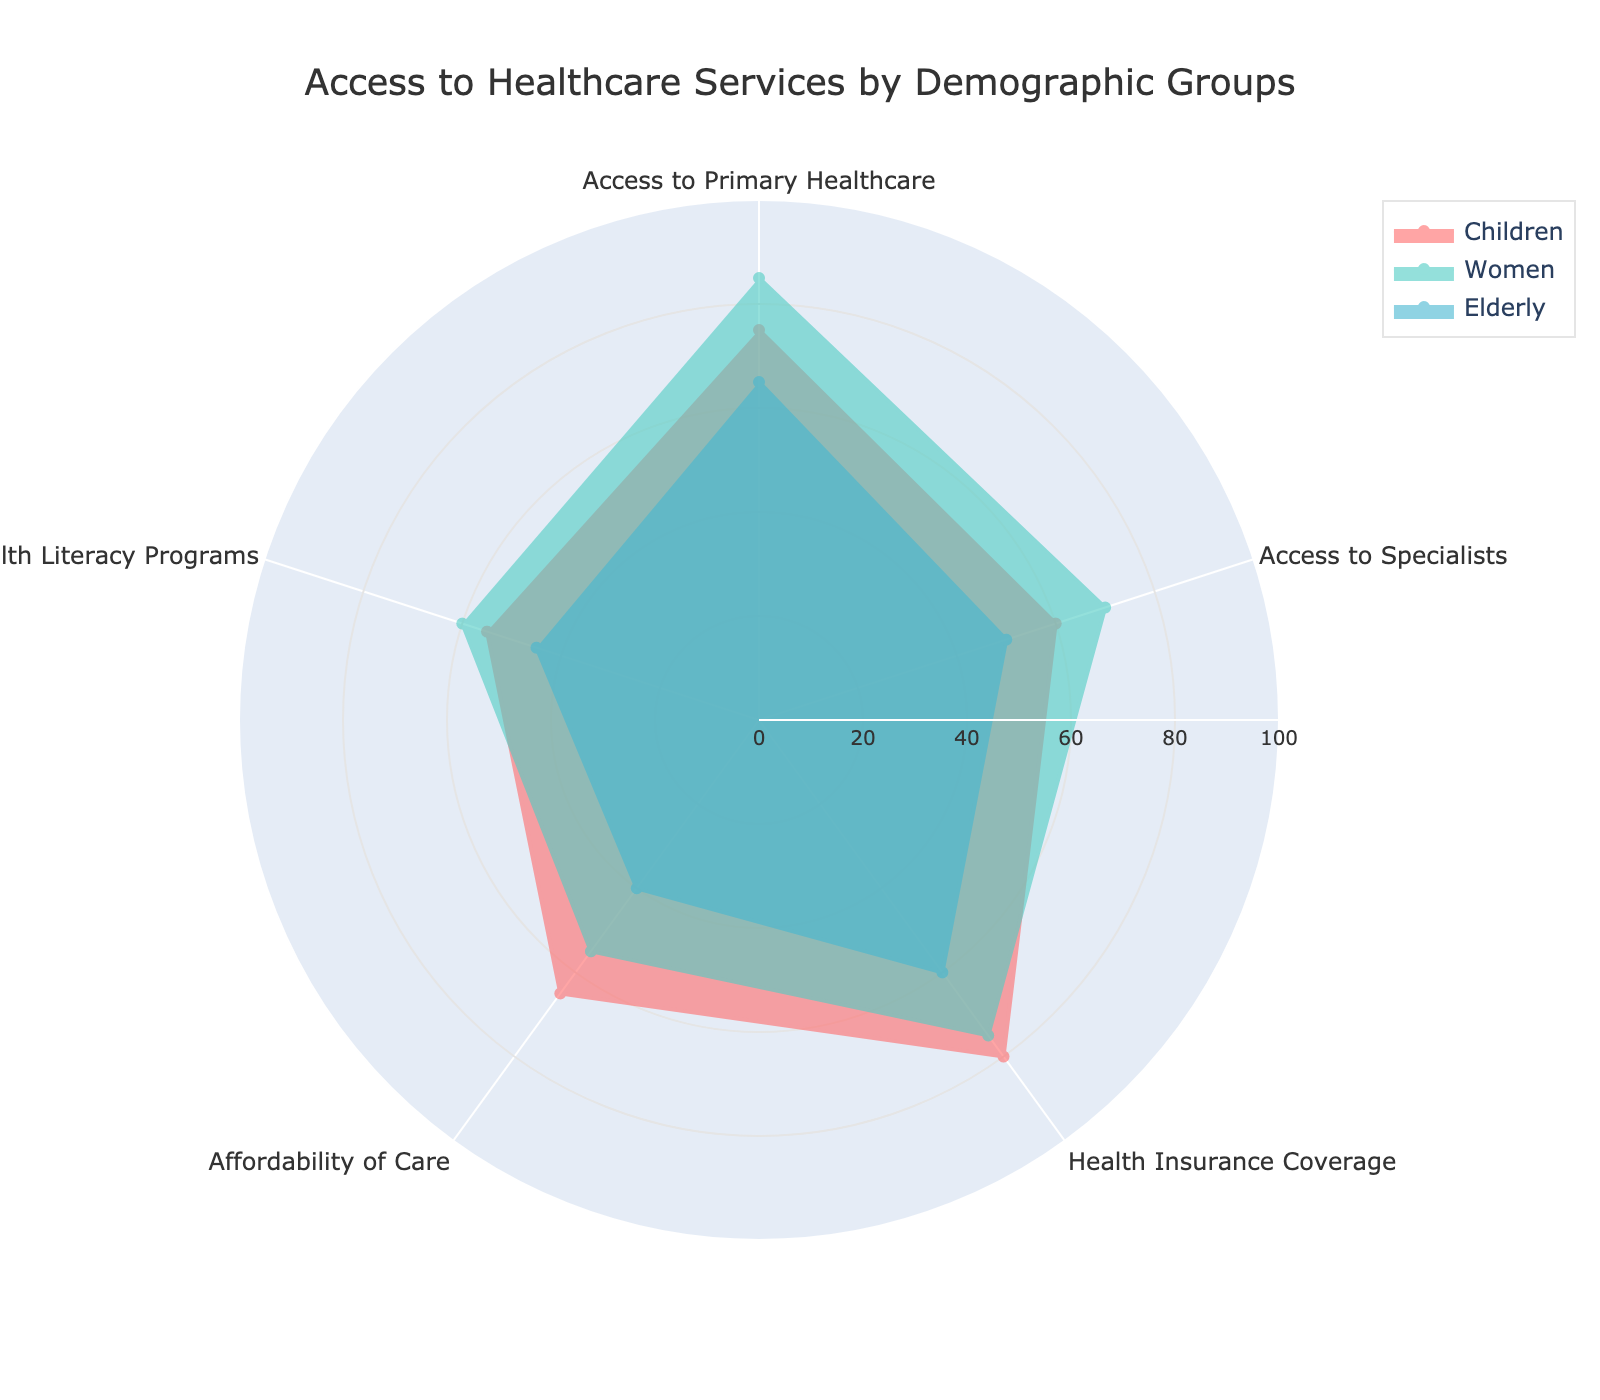what is the title of the radar chart? The title is located at the top of the chart, centered, and in a larger font size. It is meant to provide an overview of what the chart represents.
Answer: Access to Healthcare Services by Demographic Groups Which group has the highest value for Access to Primary Healthcare? To determine this, look for the segment labeled "Access to Primary Healthcare" and compare the values for Children, Women, and Elderly.
Answer: Women What is the average value for Health Insurance Coverage across all groups? Add the values for Children (80), Women (75), and Elderly (60) and divide by the number of groups (3). (80 + 75 + 60) / 3 = 71.67
Answer: 71.67 Which demographic group has the least access to Specialists? Locate the "Access to Specialists" segment and compare the values for Children, Women, and Elderly.
Answer: Elderly How many demographic groups are displayed in the radar chart? The legend or the color coding in the chart will show the demographic groups represented.
Answer: Three Which two categories have the largest difference in values for the Elderly demographic? Find the difference in values for "Access to Primary Healthcare" (65) and "Affordability of Care" (40) for Elderly. The difference is 25. Check if this is the largest by comparing other difference values for Elderly.
Answer: Access to Primary Healthcare and Affordability of Care Which category has the highest variability across all demographic groups? Calculate the range (max - min) for each category and compare them. Access to Primary Healthcare ranges from 65 to 85; Access to Specialists from 50 to 70; Health Insurance Coverage from 60 to 80; Affordability of Care from 40 to 65; Health Literacy Programs from 45 to 60. The highest variability is 25 for Access to Primary Healthcare.
Answer: Access to Primary Healthcare Is Health Literacy Programs better accessed by Children or Women? Compare the values for "Health Literacy Programs" for Children (55) and Women (60).
Answer: Women Which category shows the smallest range of access for the Women demographic group? Calculate and compare the range for each category in Women demographic: Access to Primary Healthcare (85), Access to Specialists (70), Health Insurance Coverage (75), Affordability of Care (55), Health Literacy Programs (60). The smallest range is between 55 and 85.
Answer: Affordability of Care 